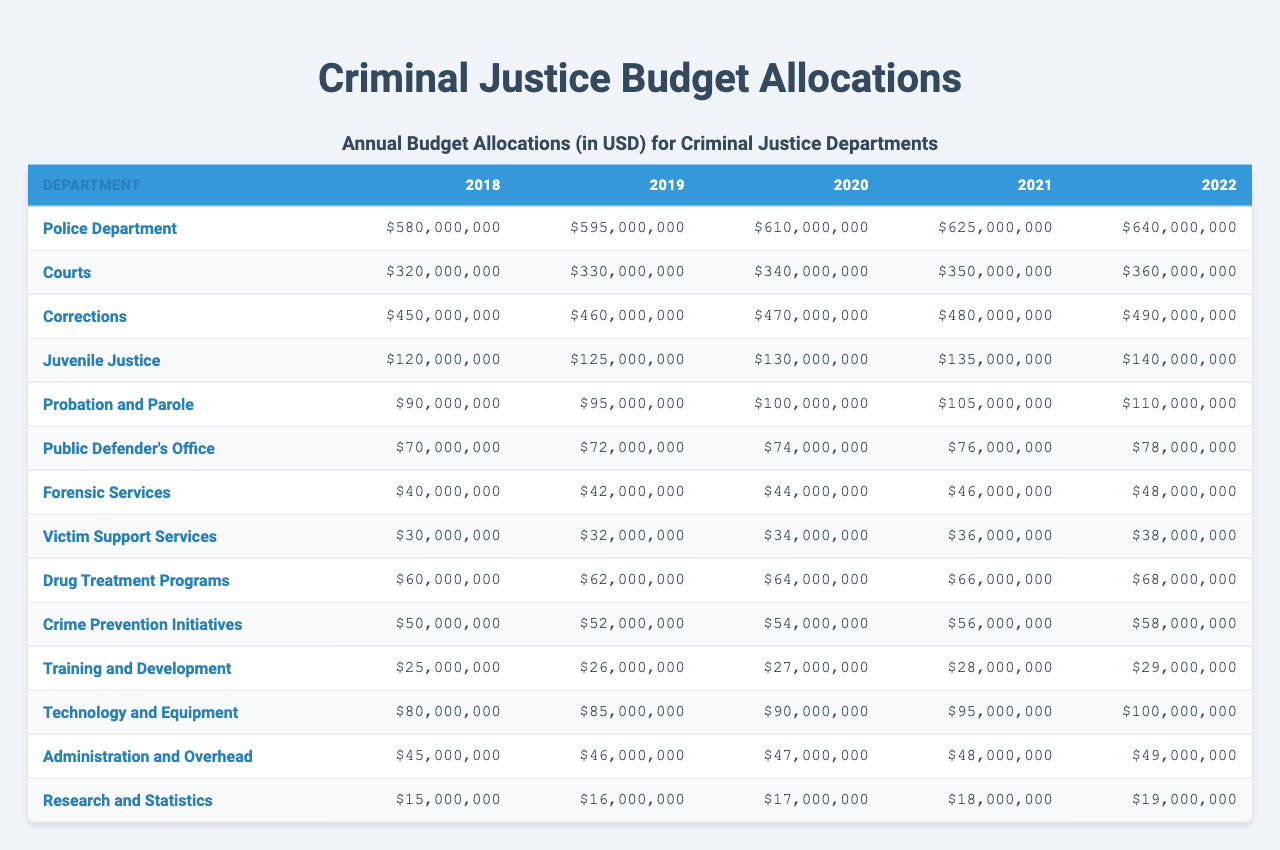What was the highest budget allocated to the Police Department? The highest budget for the Police Department was in 2022, amounting to $640,000,000. This can be determined by looking at the column for the Police Department and identifying the largest value.
Answer: $640,000,000 How much did the Courts department receive in 2021? According to the table, the budget allocated to the Courts department in 2021 is $350,000,000. This is directly found by referring to the Courts row and the corresponding year column.
Answer: $350,000,000 What was the total budget allocated for Corrections from 2018 to 2022? To find the total budget for Corrections over these years, sum the values: $450,000,000 + $460,000,000 + $470,000,000 + $480,000,000 + $490,000,000 = $2,350,000,000. Adding all values for Corrections gives this total.
Answer: $2,350,000,000 Did the budget for Juvenile Justice increase every year from 2018 to 2022? Yes, the budget for Juvenile Justice shows a consistent increase each year, from $120,000,000 in 2018 to $140,000,000 in 2022. This can be confirmed by comparing each year's budget values.
Answer: Yes What is the average budget for Drug Treatment Programs over those five years? To find the average, first sum the budgets for both years: $60,000,000 + $62,000,000 + $64,000,000 + $66,000,000 + $68,000,000 = $320,000,000. Then divide by 5 (the number of years): $320,000,000 / 5 = $64,000,000. This calculation gives us the average.
Answer: $64,000,000 Which department had the smallest budget allocation in 2018? In 2018, the smallest budget was for the Public Defender's Office, which allocated $70,000,000. By examining the first year for each department’s allocation, we can find this value.
Answer: $70,000,000 What is the percentage increase in the budget for Technology and Equipment from 2018 to 2022? The budget for Technology and Equipment increased from $80,000,000 in 2018 to $100,000,000 in 2022. To find the percentage increase: ((100 - 80) / 80) * 100 = 25%. Therefore, the percentage increase can be calculated through this formula.
Answer: 25% In which year did the Victim Support Services have a budget of exactly $30,000,000? The budget of $30,000,000 was allocated to Victim Support Services in 2018. We can locate this by looking down the Victim Support Services row and identifying the value for 2018.
Answer: 2018 Is the budget for Training and Development higher than that of Forensic Services in 2020? No, in 2020, Training and Development had a budget of $27,000,000 while Forensic Services had $44,000,000. By comparing these two specific values, we can conclude that Training and Development was lower.
Answer: No What was the increase in budget for the Public Defender’s Office from 2019 to 2020? The budget for the Public Defender’s Office increased from $72,000,000 in 2019 to $74,000,000 in 2020. The increase can be calculated as: $74,000,000 - $72,000,000 = $2,000,000. This represents the difference between the two consecutive years.
Answer: $2,000,000 